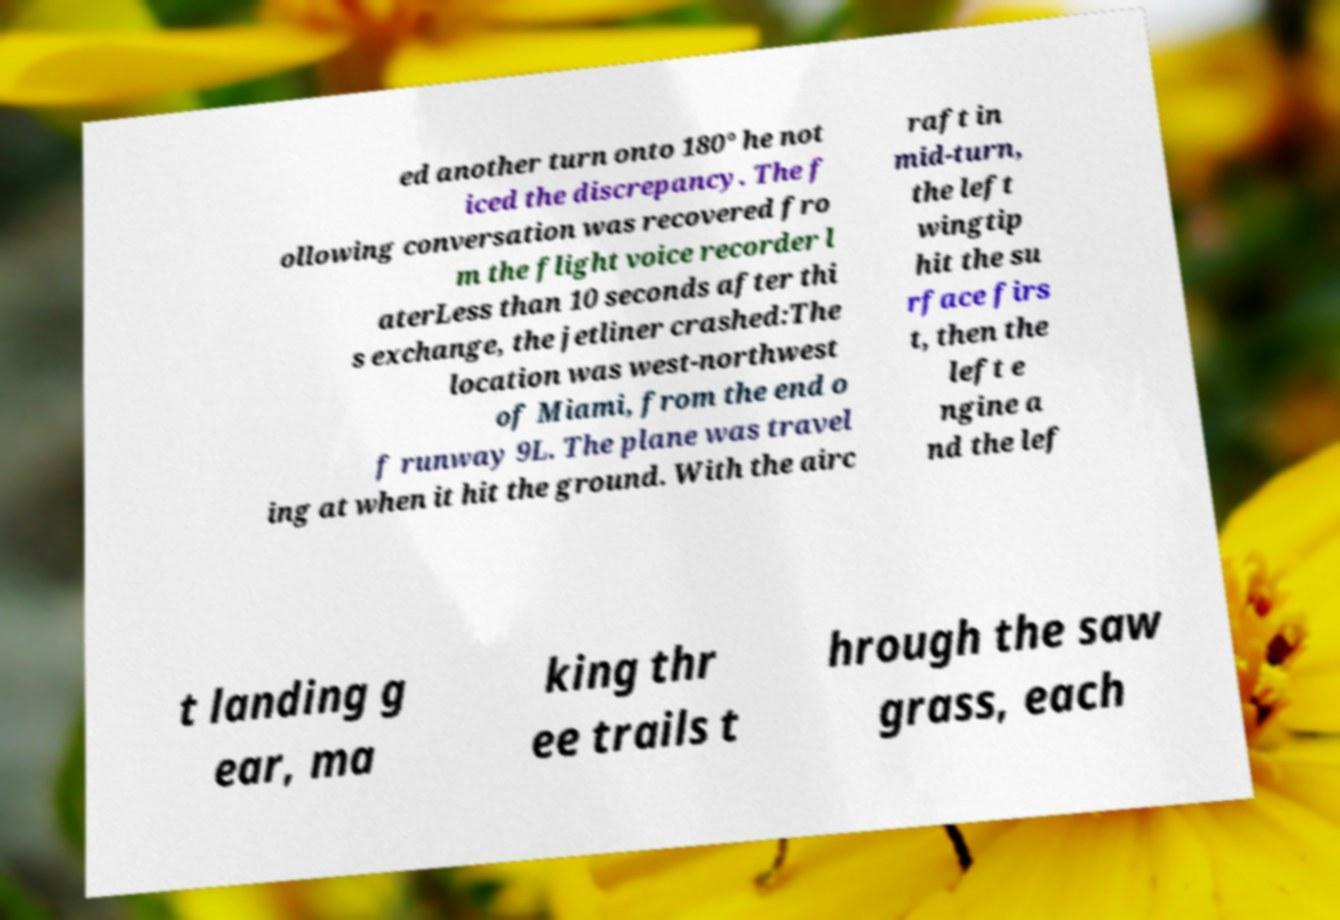Please identify and transcribe the text found in this image. ed another turn onto 180° he not iced the discrepancy. The f ollowing conversation was recovered fro m the flight voice recorder l aterLess than 10 seconds after thi s exchange, the jetliner crashed:The location was west-northwest of Miami, from the end o f runway 9L. The plane was travel ing at when it hit the ground. With the airc raft in mid-turn, the left wingtip hit the su rface firs t, then the left e ngine a nd the lef t landing g ear, ma king thr ee trails t hrough the saw grass, each 